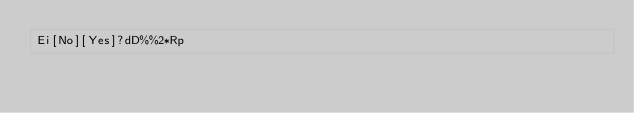Convert code to text. <code><loc_0><loc_0><loc_500><loc_500><_dc_>Ei[No][Yes]?dD%%2*Rp</code> 